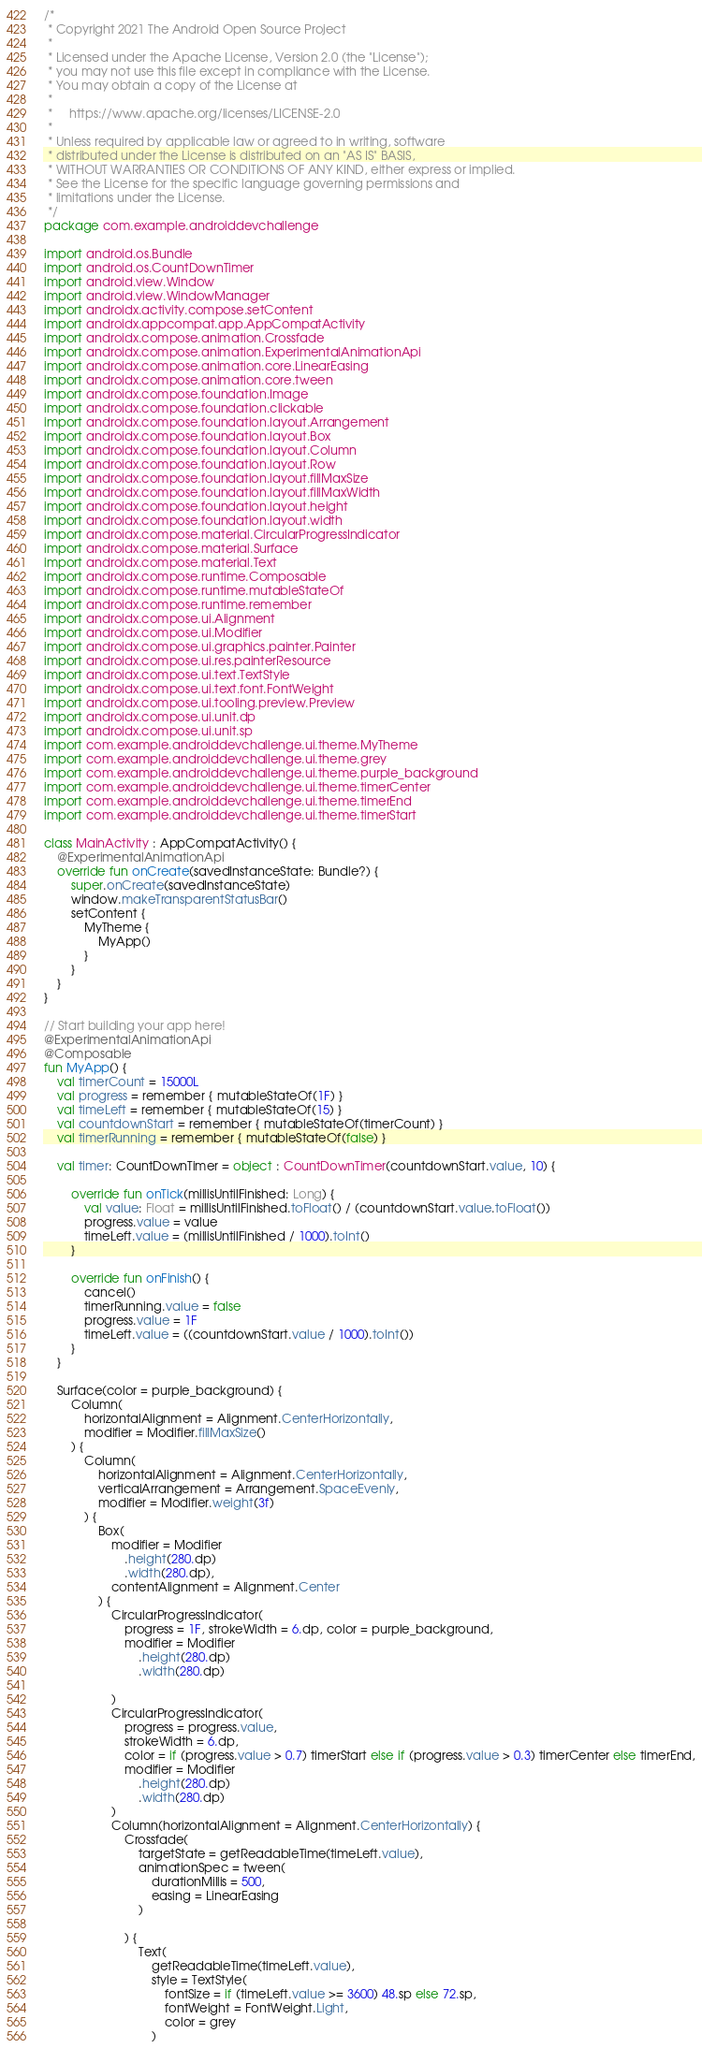Convert code to text. <code><loc_0><loc_0><loc_500><loc_500><_Kotlin_>/*
 * Copyright 2021 The Android Open Source Project
 *
 * Licensed under the Apache License, Version 2.0 (the "License");
 * you may not use this file except in compliance with the License.
 * You may obtain a copy of the License at
 *
 *     https://www.apache.org/licenses/LICENSE-2.0
 *
 * Unless required by applicable law or agreed to in writing, software
 * distributed under the License is distributed on an "AS IS" BASIS,
 * WITHOUT WARRANTIES OR CONDITIONS OF ANY KIND, either express or implied.
 * See the License for the specific language governing permissions and
 * limitations under the License.
 */
package com.example.androiddevchallenge

import android.os.Bundle
import android.os.CountDownTimer
import android.view.Window
import android.view.WindowManager
import androidx.activity.compose.setContent
import androidx.appcompat.app.AppCompatActivity
import androidx.compose.animation.Crossfade
import androidx.compose.animation.ExperimentalAnimationApi
import androidx.compose.animation.core.LinearEasing
import androidx.compose.animation.core.tween
import androidx.compose.foundation.Image
import androidx.compose.foundation.clickable
import androidx.compose.foundation.layout.Arrangement
import androidx.compose.foundation.layout.Box
import androidx.compose.foundation.layout.Column
import androidx.compose.foundation.layout.Row
import androidx.compose.foundation.layout.fillMaxSize
import androidx.compose.foundation.layout.fillMaxWidth
import androidx.compose.foundation.layout.height
import androidx.compose.foundation.layout.width
import androidx.compose.material.CircularProgressIndicator
import androidx.compose.material.Surface
import androidx.compose.material.Text
import androidx.compose.runtime.Composable
import androidx.compose.runtime.mutableStateOf
import androidx.compose.runtime.remember
import androidx.compose.ui.Alignment
import androidx.compose.ui.Modifier
import androidx.compose.ui.graphics.painter.Painter
import androidx.compose.ui.res.painterResource
import androidx.compose.ui.text.TextStyle
import androidx.compose.ui.text.font.FontWeight
import androidx.compose.ui.tooling.preview.Preview
import androidx.compose.ui.unit.dp
import androidx.compose.ui.unit.sp
import com.example.androiddevchallenge.ui.theme.MyTheme
import com.example.androiddevchallenge.ui.theme.grey
import com.example.androiddevchallenge.ui.theme.purple_background
import com.example.androiddevchallenge.ui.theme.timerCenter
import com.example.androiddevchallenge.ui.theme.timerEnd
import com.example.androiddevchallenge.ui.theme.timerStart

class MainActivity : AppCompatActivity() {
    @ExperimentalAnimationApi
    override fun onCreate(savedInstanceState: Bundle?) {
        super.onCreate(savedInstanceState)
        window.makeTransparentStatusBar()
        setContent {
            MyTheme {
                MyApp()
            }
        }
    }
}

// Start building your app here!
@ExperimentalAnimationApi
@Composable
fun MyApp() {
    val timerCount = 15000L
    val progress = remember { mutableStateOf(1F) }
    val timeLeft = remember { mutableStateOf(15) }
    val countdownStart = remember { mutableStateOf(timerCount) }
    val timerRunning = remember { mutableStateOf(false) }

    val timer: CountDownTimer = object : CountDownTimer(countdownStart.value, 10) {

        override fun onTick(millisUntilFinished: Long) {
            val value: Float = millisUntilFinished.toFloat() / (countdownStart.value.toFloat())
            progress.value = value
            timeLeft.value = (millisUntilFinished / 1000).toInt()
        }

        override fun onFinish() {
            cancel()
            timerRunning.value = false
            progress.value = 1F
            timeLeft.value = ((countdownStart.value / 1000).toInt())
        }
    }

    Surface(color = purple_background) {
        Column(
            horizontalAlignment = Alignment.CenterHorizontally,
            modifier = Modifier.fillMaxSize()
        ) {
            Column(
                horizontalAlignment = Alignment.CenterHorizontally,
                verticalArrangement = Arrangement.SpaceEvenly,
                modifier = Modifier.weight(3f)
            ) {
                Box(
                    modifier = Modifier
                        .height(280.dp)
                        .width(280.dp),
                    contentAlignment = Alignment.Center
                ) {
                    CircularProgressIndicator(
                        progress = 1F, strokeWidth = 6.dp, color = purple_background,
                        modifier = Modifier
                            .height(280.dp)
                            .width(280.dp)

                    )
                    CircularProgressIndicator(
                        progress = progress.value,
                        strokeWidth = 6.dp,
                        color = if (progress.value > 0.7) timerStart else if (progress.value > 0.3) timerCenter else timerEnd,
                        modifier = Modifier
                            .height(280.dp)
                            .width(280.dp)
                    )
                    Column(horizontalAlignment = Alignment.CenterHorizontally) {
                        Crossfade(
                            targetState = getReadableTime(timeLeft.value),
                            animationSpec = tween(
                                durationMillis = 500,
                                easing = LinearEasing
                            )

                        ) {
                            Text(
                                getReadableTime(timeLeft.value),
                                style = TextStyle(
                                    fontSize = if (timeLeft.value >= 3600) 48.sp else 72.sp,
                                    fontWeight = FontWeight.Light,
                                    color = grey
                                )</code> 